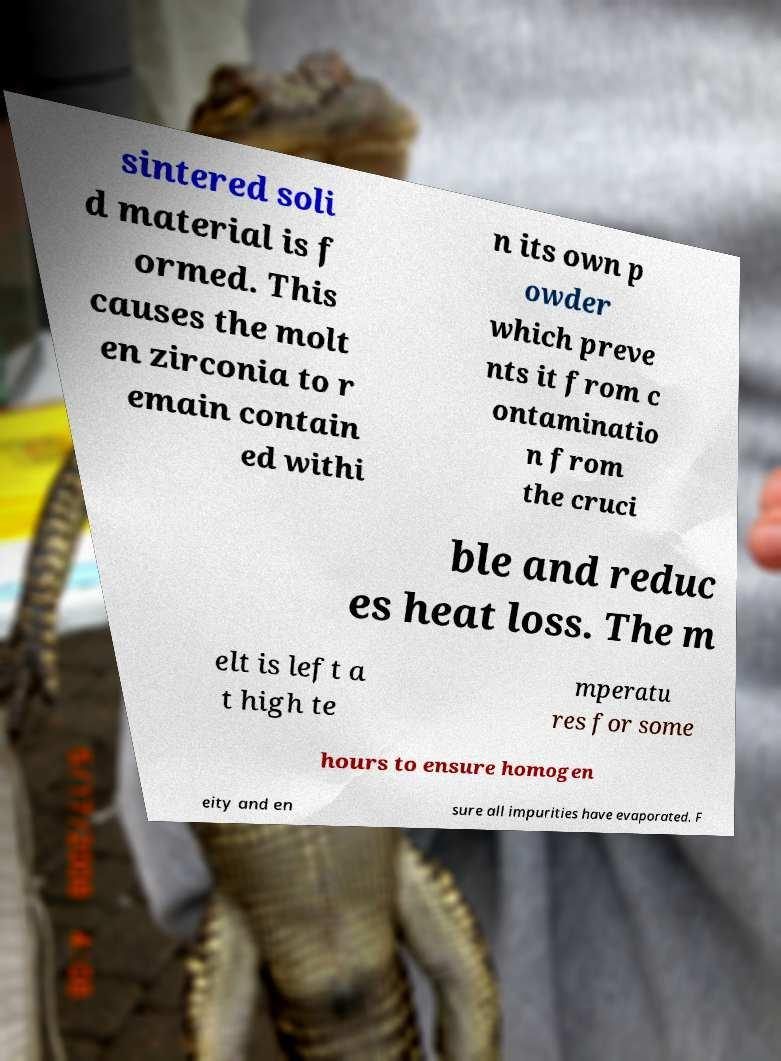For documentation purposes, I need the text within this image transcribed. Could you provide that? sintered soli d material is f ormed. This causes the molt en zirconia to r emain contain ed withi n its own p owder which preve nts it from c ontaminatio n from the cruci ble and reduc es heat loss. The m elt is left a t high te mperatu res for some hours to ensure homogen eity and en sure all impurities have evaporated. F 